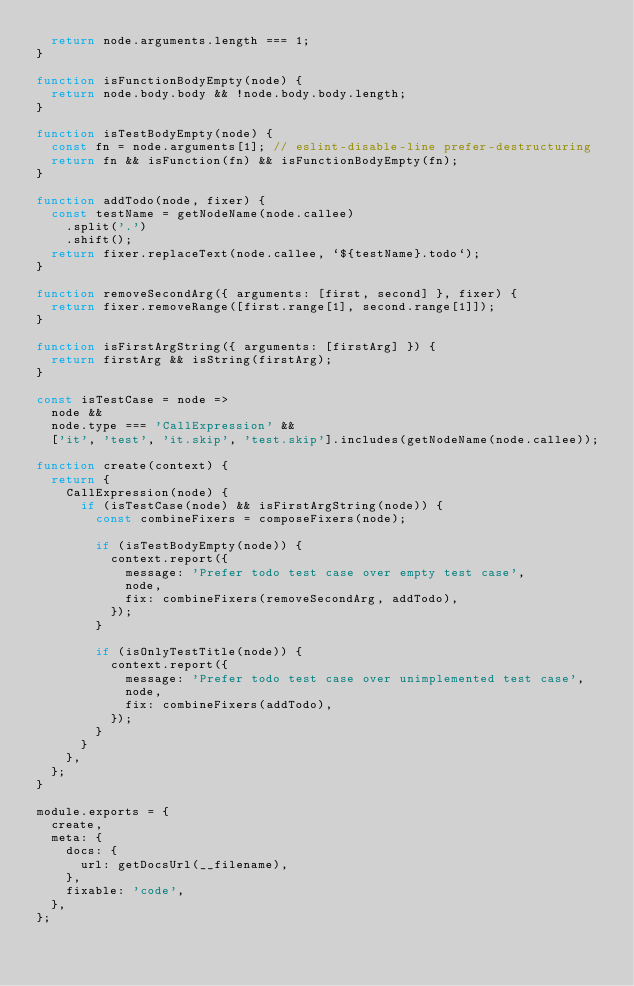Convert code to text. <code><loc_0><loc_0><loc_500><loc_500><_JavaScript_>  return node.arguments.length === 1;
}

function isFunctionBodyEmpty(node) {
  return node.body.body && !node.body.body.length;
}

function isTestBodyEmpty(node) {
  const fn = node.arguments[1]; // eslint-disable-line prefer-destructuring
  return fn && isFunction(fn) && isFunctionBodyEmpty(fn);
}

function addTodo(node, fixer) {
  const testName = getNodeName(node.callee)
    .split('.')
    .shift();
  return fixer.replaceText(node.callee, `${testName}.todo`);
}

function removeSecondArg({ arguments: [first, second] }, fixer) {
  return fixer.removeRange([first.range[1], second.range[1]]);
}

function isFirstArgString({ arguments: [firstArg] }) {
  return firstArg && isString(firstArg);
}

const isTestCase = node =>
  node &&
  node.type === 'CallExpression' &&
  ['it', 'test', 'it.skip', 'test.skip'].includes(getNodeName(node.callee));

function create(context) {
  return {
    CallExpression(node) {
      if (isTestCase(node) && isFirstArgString(node)) {
        const combineFixers = composeFixers(node);

        if (isTestBodyEmpty(node)) {
          context.report({
            message: 'Prefer todo test case over empty test case',
            node,
            fix: combineFixers(removeSecondArg, addTodo),
          });
        }

        if (isOnlyTestTitle(node)) {
          context.report({
            message: 'Prefer todo test case over unimplemented test case',
            node,
            fix: combineFixers(addTodo),
          });
        }
      }
    },
  };
}

module.exports = {
  create,
  meta: {
    docs: {
      url: getDocsUrl(__filename),
    },
    fixable: 'code',
  },
};
</code> 